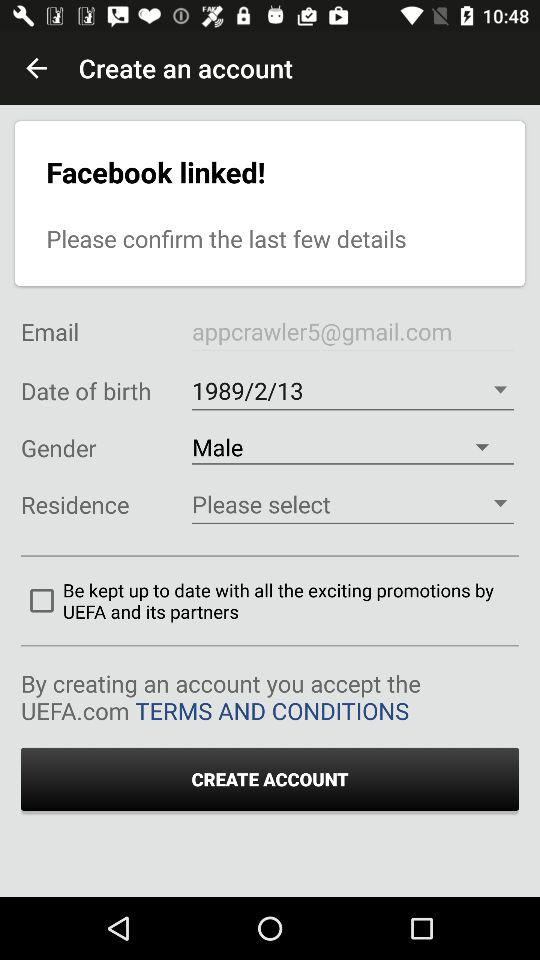What is the gender? The gender is male. 